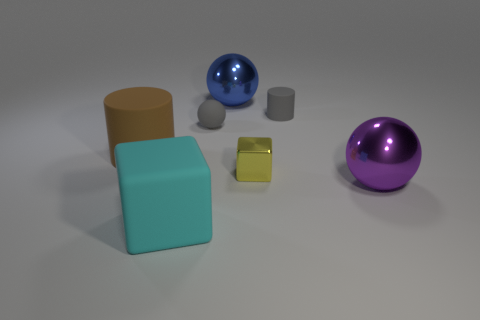There is a gray matte ball that is to the left of the sphere that is in front of the brown matte cylinder; what is its size?
Offer a terse response. Small. There is a big matte object that is on the left side of the big cyan object; does it have the same shape as the tiny yellow thing?
Your answer should be compact. No. There is a tiny gray object that is the same shape as the brown rubber object; what is its material?
Your response must be concise. Rubber. How many things are either balls that are to the left of the big purple metal thing or cubes that are in front of the tiny metal object?
Make the answer very short. 3. There is a large rubber block; is it the same color as the matte cylinder behind the large brown object?
Keep it short and to the point. No. What shape is the tiny yellow object that is made of the same material as the purple thing?
Make the answer very short. Cube. How many small matte objects are there?
Your answer should be very brief. 2. How many things are either tiny gray objects that are left of the tiny cylinder or tiny brown metal cylinders?
Make the answer very short. 1. Does the thing left of the large cyan object have the same color as the rubber block?
Provide a short and direct response. No. What number of other objects are the same color as the tiny metal object?
Give a very brief answer. 0. 